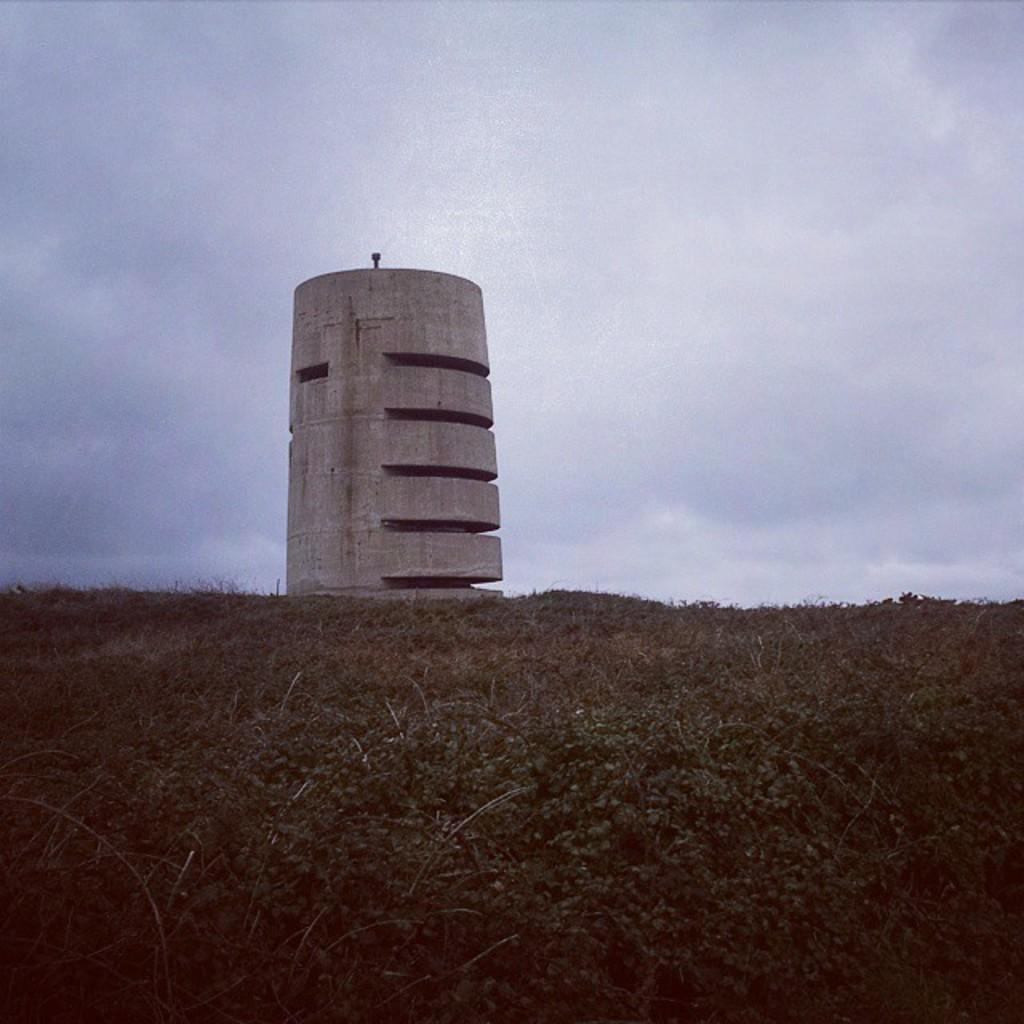What type of living organisms can be seen in the image? Plants can be seen in the image. What is located in the middle of the image? There is a tower in the middle of the image. What can be seen in the background of the image? Clouds are visible in the background of the image. What type of ink is used to draw the clouds in the image? There is no indication that the clouds in the image were drawn; they are a natural part of the sky. How does the elbow of the tower appear in the image? There is no mention of an elbow in the image, as it refers to a part of the human body and not a feature of a tower. 